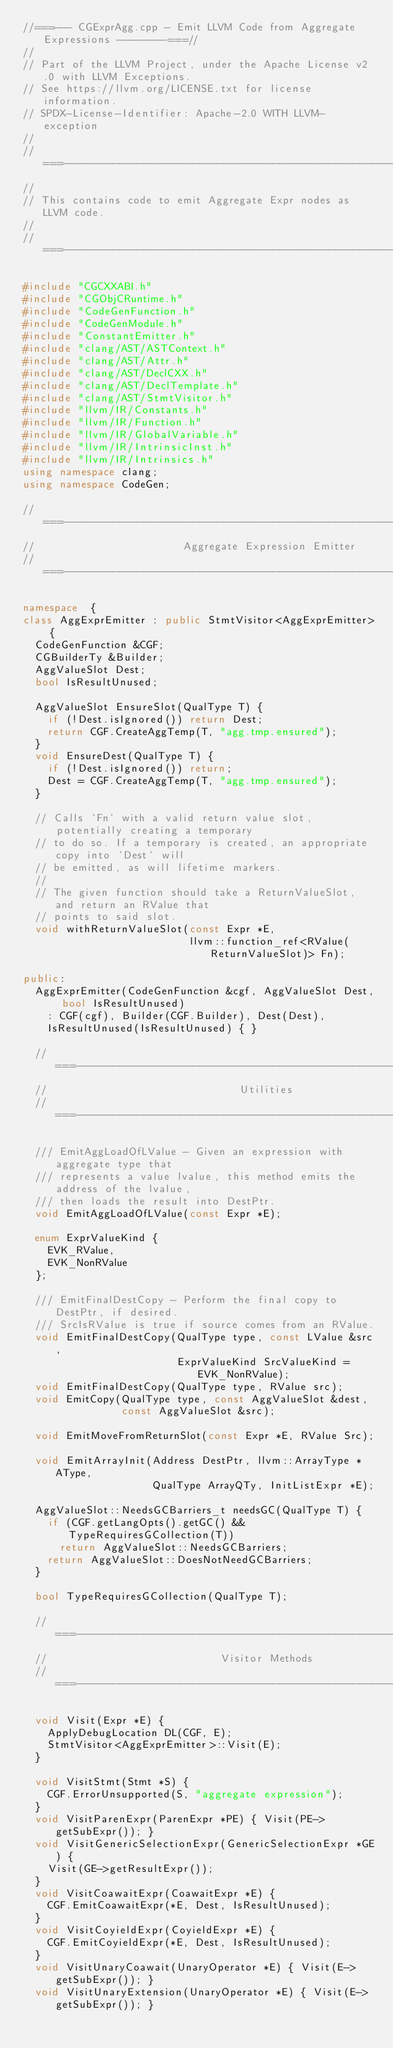Convert code to text. <code><loc_0><loc_0><loc_500><loc_500><_C++_>//===--- CGExprAgg.cpp - Emit LLVM Code from Aggregate Expressions --------===//
//
// Part of the LLVM Project, under the Apache License v2.0 with LLVM Exceptions.
// See https://llvm.org/LICENSE.txt for license information.
// SPDX-License-Identifier: Apache-2.0 WITH LLVM-exception
//
//===----------------------------------------------------------------------===//
//
// This contains code to emit Aggregate Expr nodes as LLVM code.
//
//===----------------------------------------------------------------------===//

#include "CGCXXABI.h"
#include "CGObjCRuntime.h"
#include "CodeGenFunction.h"
#include "CodeGenModule.h"
#include "ConstantEmitter.h"
#include "clang/AST/ASTContext.h"
#include "clang/AST/Attr.h"
#include "clang/AST/DeclCXX.h"
#include "clang/AST/DeclTemplate.h"
#include "clang/AST/StmtVisitor.h"
#include "llvm/IR/Constants.h"
#include "llvm/IR/Function.h"
#include "llvm/IR/GlobalVariable.h"
#include "llvm/IR/IntrinsicInst.h"
#include "llvm/IR/Intrinsics.h"
using namespace clang;
using namespace CodeGen;

//===----------------------------------------------------------------------===//
//                        Aggregate Expression Emitter
//===----------------------------------------------------------------------===//

namespace  {
class AggExprEmitter : public StmtVisitor<AggExprEmitter> {
  CodeGenFunction &CGF;
  CGBuilderTy &Builder;
  AggValueSlot Dest;
  bool IsResultUnused;

  AggValueSlot EnsureSlot(QualType T) {
    if (!Dest.isIgnored()) return Dest;
    return CGF.CreateAggTemp(T, "agg.tmp.ensured");
  }
  void EnsureDest(QualType T) {
    if (!Dest.isIgnored()) return;
    Dest = CGF.CreateAggTemp(T, "agg.tmp.ensured");
  }

  // Calls `Fn` with a valid return value slot, potentially creating a temporary
  // to do so. If a temporary is created, an appropriate copy into `Dest` will
  // be emitted, as will lifetime markers.
  //
  // The given function should take a ReturnValueSlot, and return an RValue that
  // points to said slot.
  void withReturnValueSlot(const Expr *E,
                           llvm::function_ref<RValue(ReturnValueSlot)> Fn);

public:
  AggExprEmitter(CodeGenFunction &cgf, AggValueSlot Dest, bool IsResultUnused)
    : CGF(cgf), Builder(CGF.Builder), Dest(Dest),
    IsResultUnused(IsResultUnused) { }

  //===--------------------------------------------------------------------===//
  //                               Utilities
  //===--------------------------------------------------------------------===//

  /// EmitAggLoadOfLValue - Given an expression with aggregate type that
  /// represents a value lvalue, this method emits the address of the lvalue,
  /// then loads the result into DestPtr.
  void EmitAggLoadOfLValue(const Expr *E);

  enum ExprValueKind {
    EVK_RValue,
    EVK_NonRValue
  };

  /// EmitFinalDestCopy - Perform the final copy to DestPtr, if desired.
  /// SrcIsRValue is true if source comes from an RValue.
  void EmitFinalDestCopy(QualType type, const LValue &src,
                         ExprValueKind SrcValueKind = EVK_NonRValue);
  void EmitFinalDestCopy(QualType type, RValue src);
  void EmitCopy(QualType type, const AggValueSlot &dest,
                const AggValueSlot &src);

  void EmitMoveFromReturnSlot(const Expr *E, RValue Src);

  void EmitArrayInit(Address DestPtr, llvm::ArrayType *AType,
                     QualType ArrayQTy, InitListExpr *E);

  AggValueSlot::NeedsGCBarriers_t needsGC(QualType T) {
    if (CGF.getLangOpts().getGC() && TypeRequiresGCollection(T))
      return AggValueSlot::NeedsGCBarriers;
    return AggValueSlot::DoesNotNeedGCBarriers;
  }

  bool TypeRequiresGCollection(QualType T);

  //===--------------------------------------------------------------------===//
  //                            Visitor Methods
  //===--------------------------------------------------------------------===//

  void Visit(Expr *E) {
    ApplyDebugLocation DL(CGF, E);
    StmtVisitor<AggExprEmitter>::Visit(E);
  }

  void VisitStmt(Stmt *S) {
    CGF.ErrorUnsupported(S, "aggregate expression");
  }
  void VisitParenExpr(ParenExpr *PE) { Visit(PE->getSubExpr()); }
  void VisitGenericSelectionExpr(GenericSelectionExpr *GE) {
    Visit(GE->getResultExpr());
  }
  void VisitCoawaitExpr(CoawaitExpr *E) {
    CGF.EmitCoawaitExpr(*E, Dest, IsResultUnused);
  }
  void VisitCoyieldExpr(CoyieldExpr *E) {
    CGF.EmitCoyieldExpr(*E, Dest, IsResultUnused);
  }
  void VisitUnaryCoawait(UnaryOperator *E) { Visit(E->getSubExpr()); }
  void VisitUnaryExtension(UnaryOperator *E) { Visit(E->getSubExpr()); }</code> 